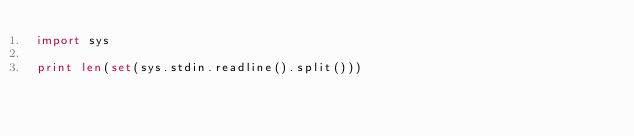<code> <loc_0><loc_0><loc_500><loc_500><_Python_>import sys

print len(set(sys.stdin.readline().split()))</code> 